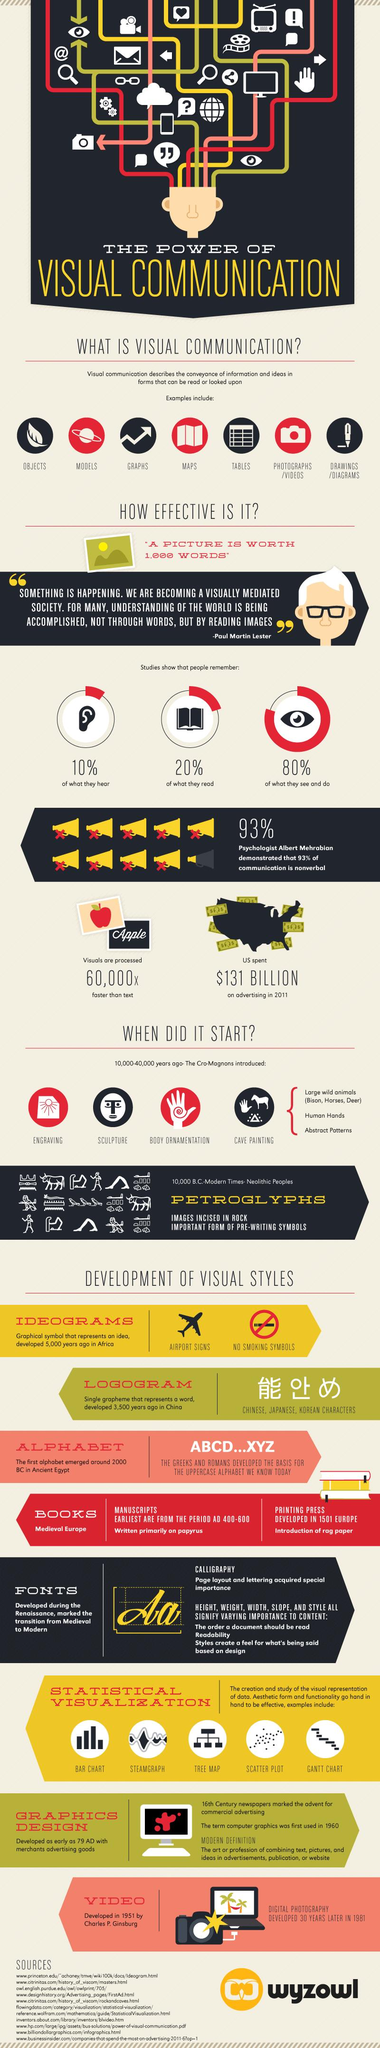List a handful of essential elements in this visual. Ideograms, a type of writing system, were developed in Africa. According to studies, what people remember the second most is what they read. According to studies, people tend to remember what they see and do the most. Petroglyphs are an important form of pre-writing symbols. During the time period of 10,000 to 40,000 years ago, Cro-Magnons introduced a range of new cultural practices that include engraving, sculpture, body ornamentation, and cave painting. 